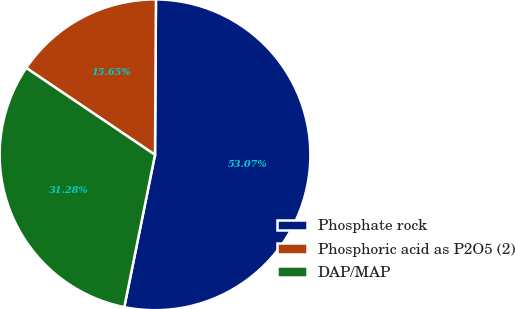Convert chart to OTSL. <chart><loc_0><loc_0><loc_500><loc_500><pie_chart><fcel>Phosphate rock<fcel>Phosphoric acid as P2O5 (2)<fcel>DAP/MAP<nl><fcel>53.07%<fcel>15.65%<fcel>31.28%<nl></chart> 